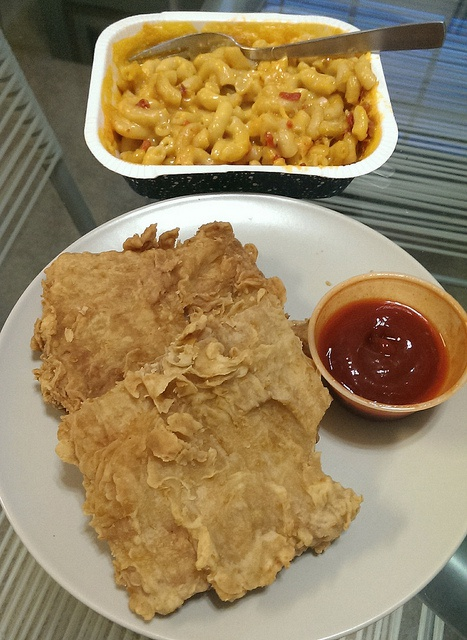Describe the objects in this image and their specific colors. I can see dining table in black and gray tones, bowl in black, maroon, red, and tan tones, chair in black, gray, and darkgreen tones, and fork in black and olive tones in this image. 